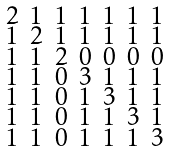<formula> <loc_0><loc_0><loc_500><loc_500>\begin{smallmatrix} 2 & 1 & 1 & 1 & 1 & 1 & 1 \\ 1 & 2 & 1 & 1 & 1 & 1 & 1 \\ 1 & 1 & 2 & 0 & 0 & 0 & 0 \\ 1 & 1 & 0 & 3 & 1 & 1 & 1 \\ 1 & 1 & 0 & 1 & 3 & 1 & 1 \\ 1 & 1 & 0 & 1 & 1 & 3 & 1 \\ 1 & 1 & 0 & 1 & 1 & 1 & 3 \end{smallmatrix}</formula> 